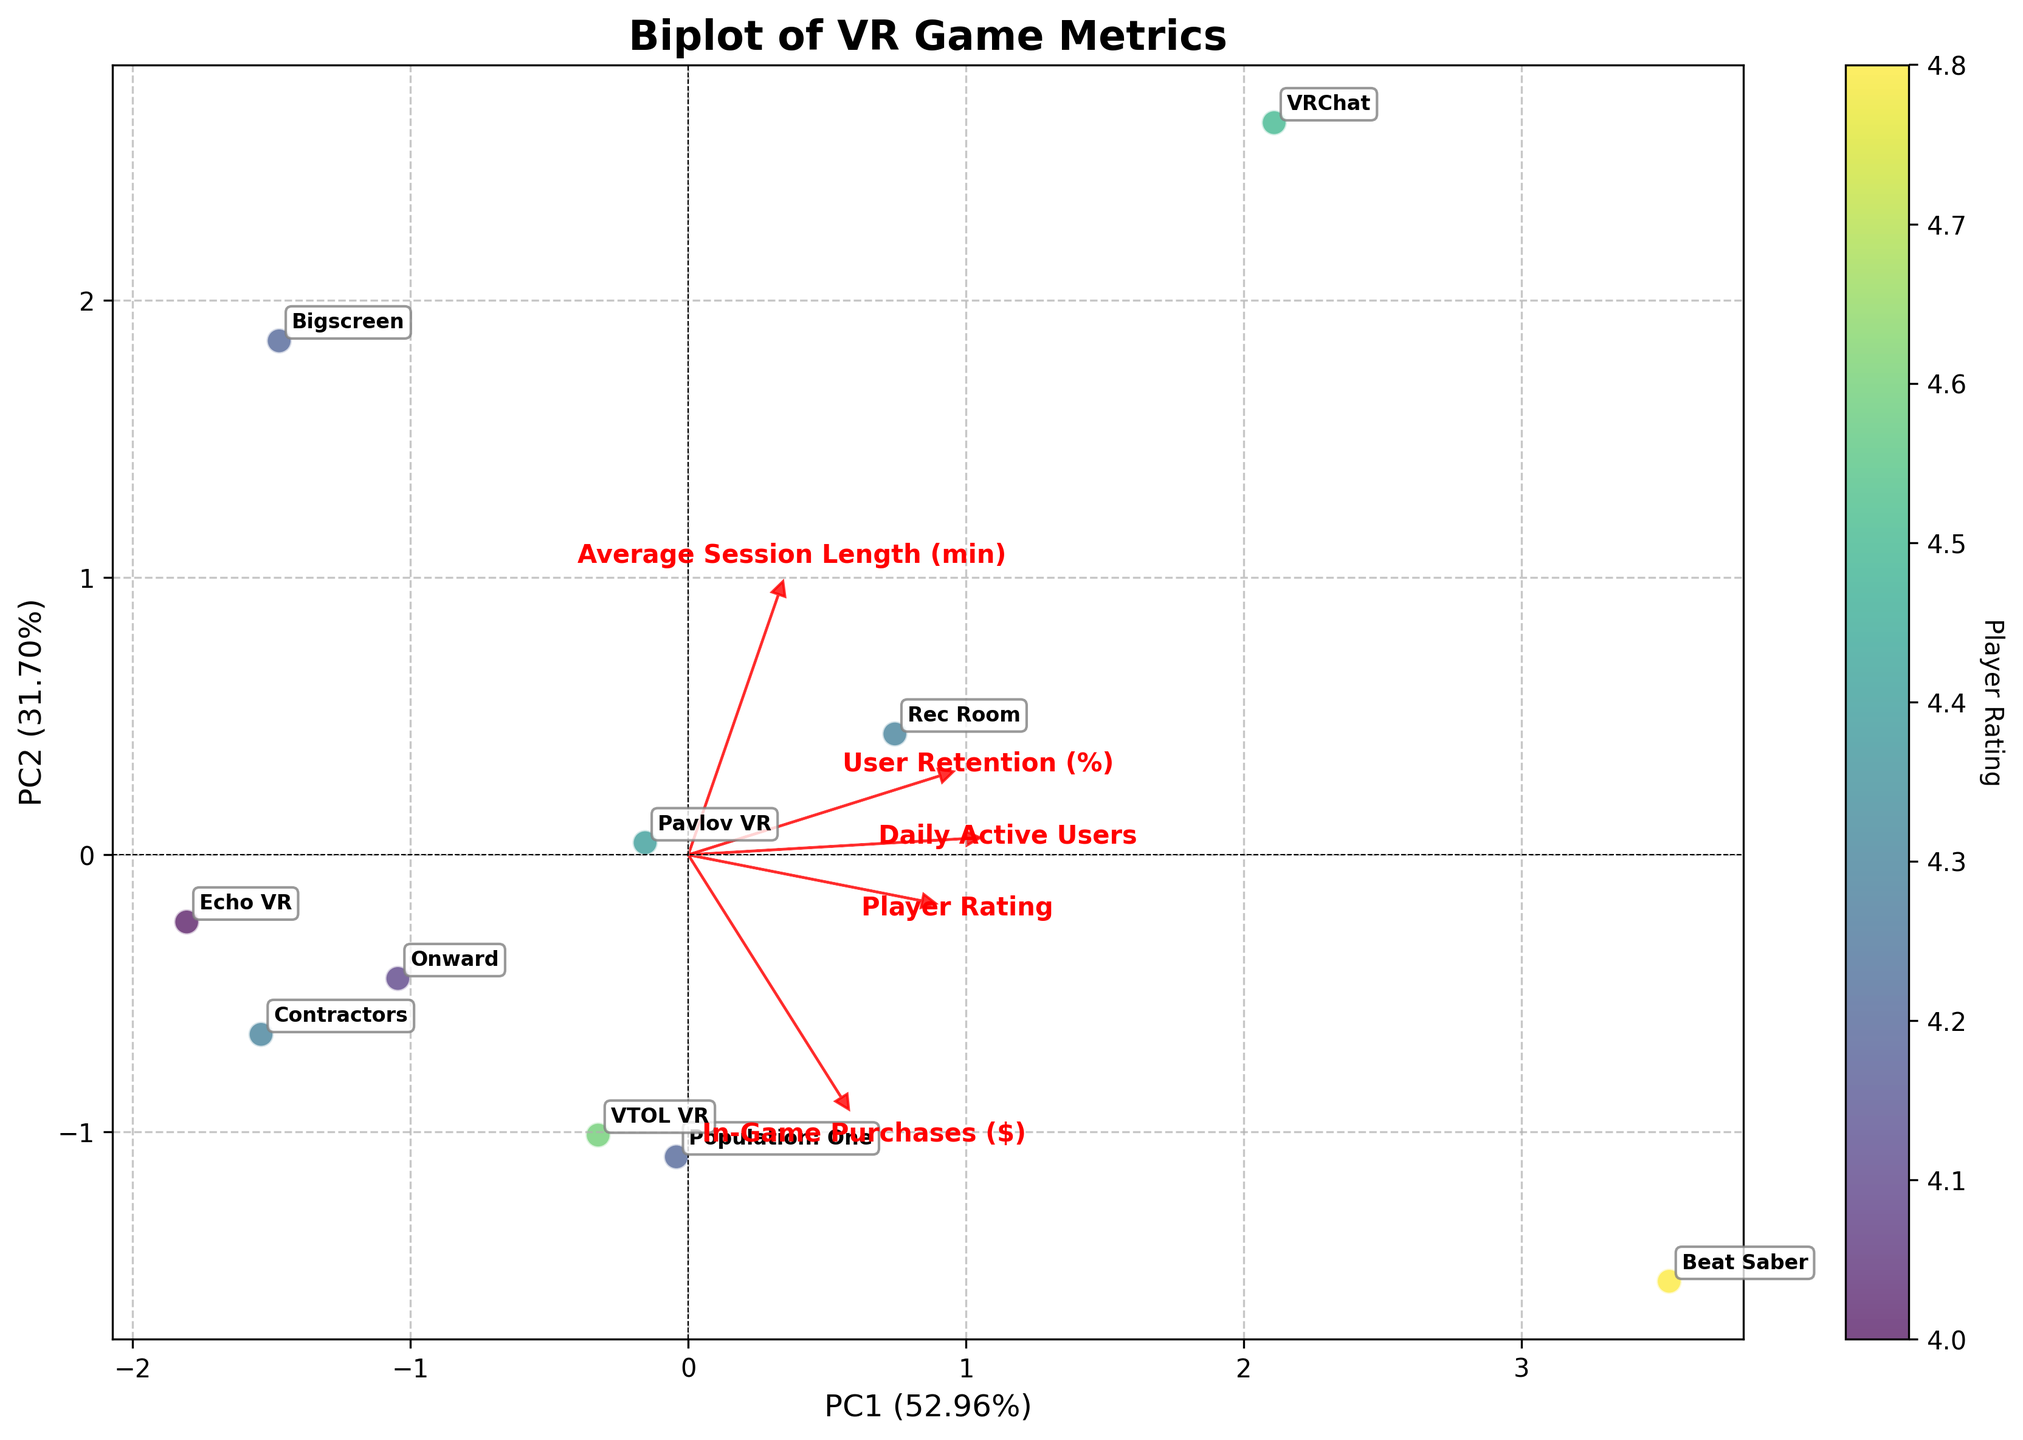What is the title of the biplot? The title of the plot is typically located at the top of the figure and is prominently displayed to summarize what the figure represents. In this case, it reads "Biplot of VR Game Metrics".
Answer: Biplot of VR Game Metrics How are the games represented in the biplot? The games are represented as points (or marks) scattered across the plot, with each point labeled by the game's name. This helps in identifying the position of each game on the biplot.
Answer: As labeled points What do the arrows on the biplot signify? The arrows represent the original features (or variables), showing their direction and correlation with the principal components. The longer the arrow, the stronger the correlation of that feature with the principal components.
Answer: Original features What feature seems to contribute the most to the first principal component? The feature with the longest arrow along the direction of the first principal component (PC1) contributes the most. As seen in the plot, "Daily Active Users" has a long arrow in the direction of PC1, suggesting a strong contribution.
Answer: Daily Active Users Which game has the highest Player Rating and how can you tell? The color gradient (viridis) represents Player Rating. The point with the most intense color (indicative of highest rating) and its label “Beat Saber” can be identified as having the highest Player Rating.
Answer: Beat Saber What is the relationship between "Average Session Length" and the second principal component (PC2)? By looking at the direction and length of the arrow labeled "Average Session Length (min)", one can see if it aligns with PC2. The arrow pointing upwards (positively correlated with PC2) suggests a strong relationship.
Answer: Strong positive correlation Which game has the shortest "Average Session Length" and how did you determine it? By examining the annotations and finding the point closest to the arrow base labeled “Echo VR”, which has the least y-axis displacement indicative of shorter session length.
Answer: Echo VR How do "In-Game Purchases" compare between "Beat Saber" and "VRChat"? By observing the location of each game point and the direction of the arrow labeled “In-Game Purchases ($)”, "Beat Saber" lies closer to higher PC1 values associated with higher "In-Game Purchases" as the arrow direction suggests.
Answer: Beat Saber > VRChat Can you determine any game having both high "User Retention" and "Player Rating"? By finding points near the arrows labeled "User Retention (%)" and "Player Rating" which point in somewhat the same direction. "VRChat" and "Beat Saber" are located in a region influenced by both high "User Retention" and high "Player Rating".
Answer: VRChat and Beat Saber Which features are positively correlated based on the biplot arrows? Two features are positively correlated if their arrows point in a similar direction. Observing the arrows, "Daily Active Users" and "In-Game Purchases ($)" point in similar directions, indicating positive correlation.
Answer: Daily Active Users and In-Game Purchases ($) 